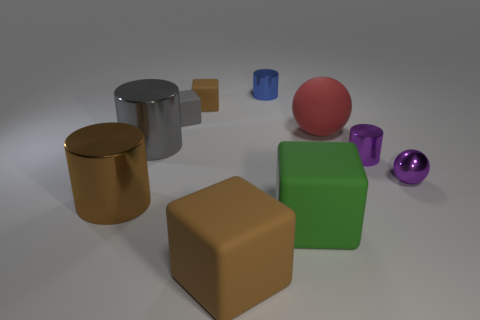Is there any other thing that has the same color as the tiny sphere?
Offer a terse response. Yes. Is the blue cylinder the same size as the red matte ball?
Provide a succinct answer. No. There is a brown thing that is in front of the large matte sphere and left of the large brown rubber cube; what size is it?
Your answer should be compact. Large. How many large gray cylinders have the same material as the purple cylinder?
Your answer should be compact. 1. What color is the tiny metal ball?
Your answer should be compact. Purple. There is a big brown thing right of the large brown metallic thing; is it the same shape as the large red object?
Provide a short and direct response. No. How many things are matte things behind the small purple metal ball or metallic things?
Offer a terse response. 8. Are there any small red metallic objects that have the same shape as the big green matte object?
Offer a terse response. No. There is a brown metal thing that is the same size as the green rubber cube; what is its shape?
Offer a very short reply. Cylinder. What is the shape of the large brown object that is behind the big matte thing on the left side of the shiny thing behind the matte ball?
Give a very brief answer. Cylinder. 